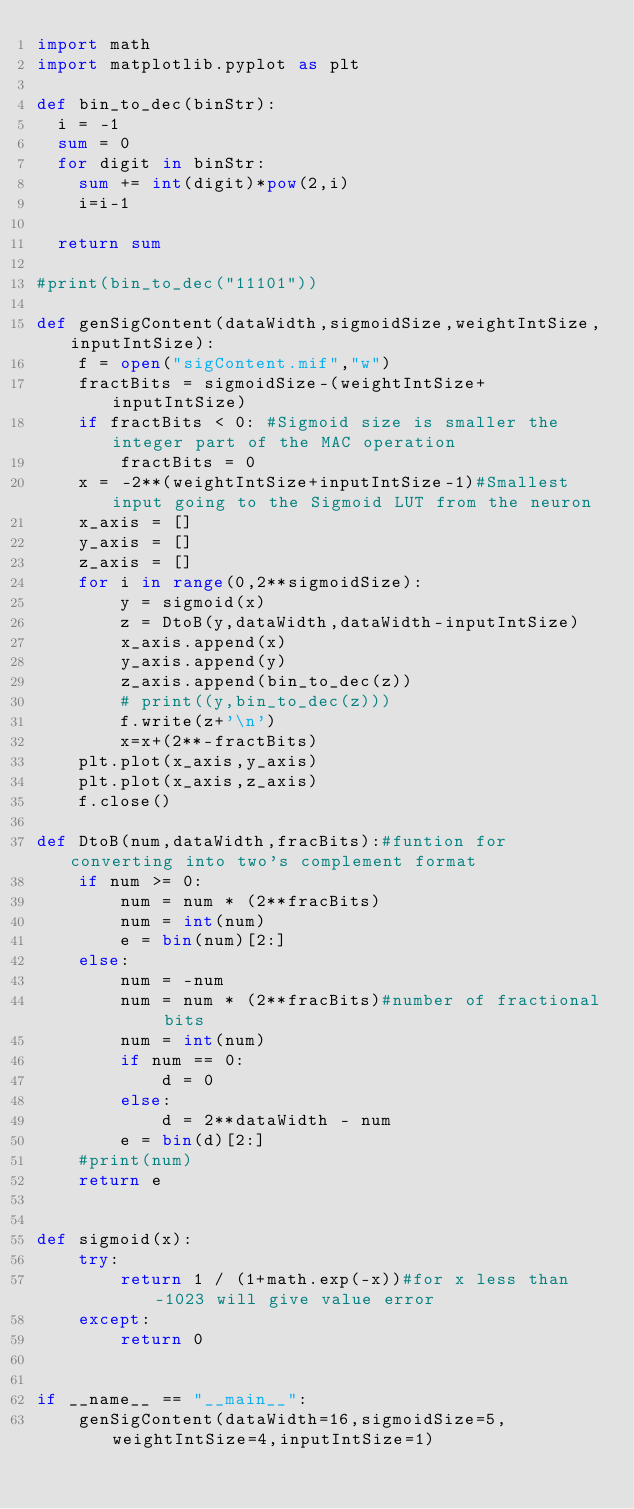Convert code to text. <code><loc_0><loc_0><loc_500><loc_500><_Python_>import math
import matplotlib.pyplot as plt

def bin_to_dec(binStr):
  i = -1
  sum = 0
  for digit in binStr:
    sum += int(digit)*pow(2,i)
    i=i-1

  return sum

#print(bin_to_dec("11101"))

def genSigContent(dataWidth,sigmoidSize,weightIntSize,inputIntSize):
    f = open("sigContent.mif","w")
    fractBits = sigmoidSize-(weightIntSize+inputIntSize) 
    if fractBits < 0: #Sigmoid size is smaller the integer part of the MAC operation
        fractBits = 0
    x = -2**(weightIntSize+inputIntSize-1)#Smallest input going to the Sigmoid LUT from the neuron
    x_axis = []
    y_axis = []
    z_axis = []
    for i in range(0,2**sigmoidSize):
        y = sigmoid(x)
        z = DtoB(y,dataWidth,dataWidth-inputIntSize) 
        x_axis.append(x)
        y_axis.append(y)
        z_axis.append(bin_to_dec(z))
        # print((y,bin_to_dec(z)))    
        f.write(z+'\n')
        x=x+(2**-fractBits)
    plt.plot(x_axis,y_axis)
    plt.plot(x_axis,z_axis)
    f.close()

def DtoB(num,dataWidth,fracBits):#funtion for converting into two's complement format
    if num >= 0:
        num = num * (2**fracBits)
        num = int(num)
        e = bin(num)[2:]
    else:
        num = -num
        num = num * (2**fracBits)#number of fractional bits
        num = int(num)
        if num == 0:
            d = 0
        else:
            d = 2**dataWidth - num
        e = bin(d)[2:]
    #print(num)
    return e
    
    
def sigmoid(x):
    try:
        return 1 / (1+math.exp(-x))#for x less than -1023 will give value error
    except:
        return 0
        
        
if __name__ == "__main__":
    genSigContent(dataWidth=16,sigmoidSize=5,weightIntSize=4,inputIntSize=1)
</code> 